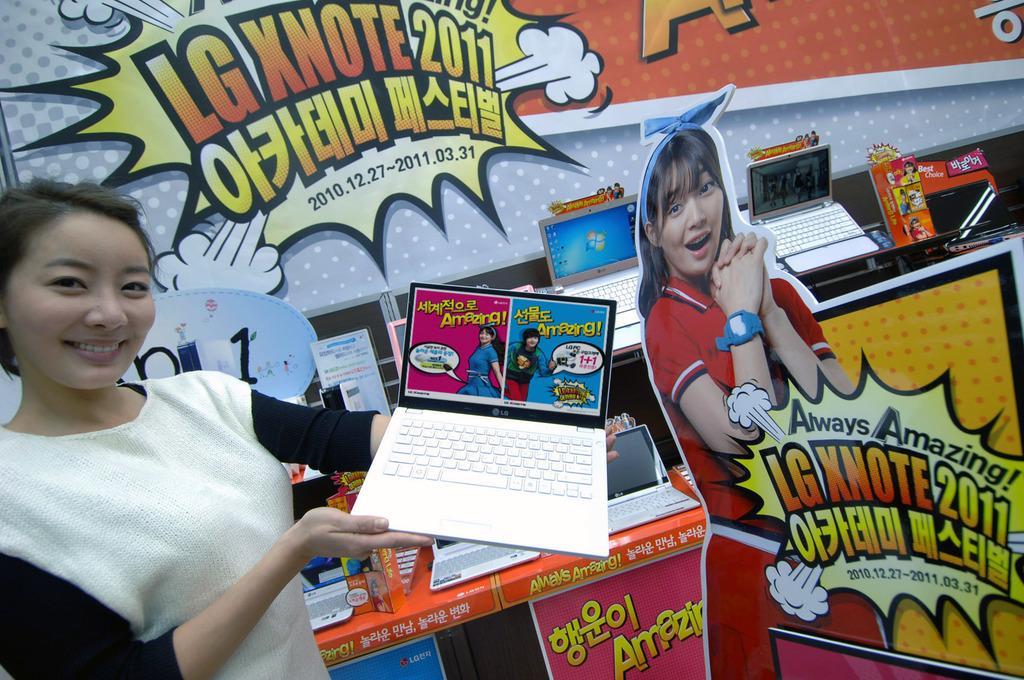In one or two sentences, can you explain what this image depicts? In this image we can see a woman standing and holding laptop in her hands. In the background we can see posters and laptops placed on the desks. 